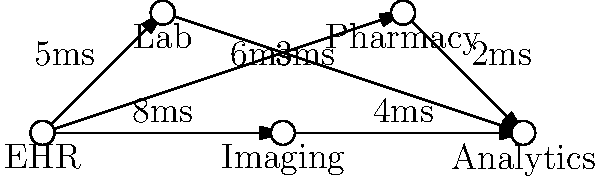Given the network diagram of a healthcare system integration, what is the minimum latency for data to flow from the EHR system to the Analytics system? Assume data must pass through at least one intermediary system. To find the minimum latency, we need to analyze all possible paths from EHR to Analytics through at least one intermediary system:

1. EHR -> Lab -> Analytics:
   Latency = 5ms + 3ms = 8ms

2. EHR -> Imaging -> Analytics:
   Latency = 8ms + 4ms = 12ms

3. EHR -> Pharmacy -> Analytics:
   Latency = 6ms + 2ms = 8ms

Comparing these latencies:
- Path 1: 8ms
- Path 2: 12ms
- Path 3: 8ms

The minimum latency is 8ms, which can be achieved through two paths:
1. EHR -> Lab -> Analytics
2. EHR -> Pharmacy -> Analytics

Both of these paths provide the minimum latency of 8ms for data to flow from the EHR system to the Analytics system while passing through one intermediary system.
Answer: 8ms 